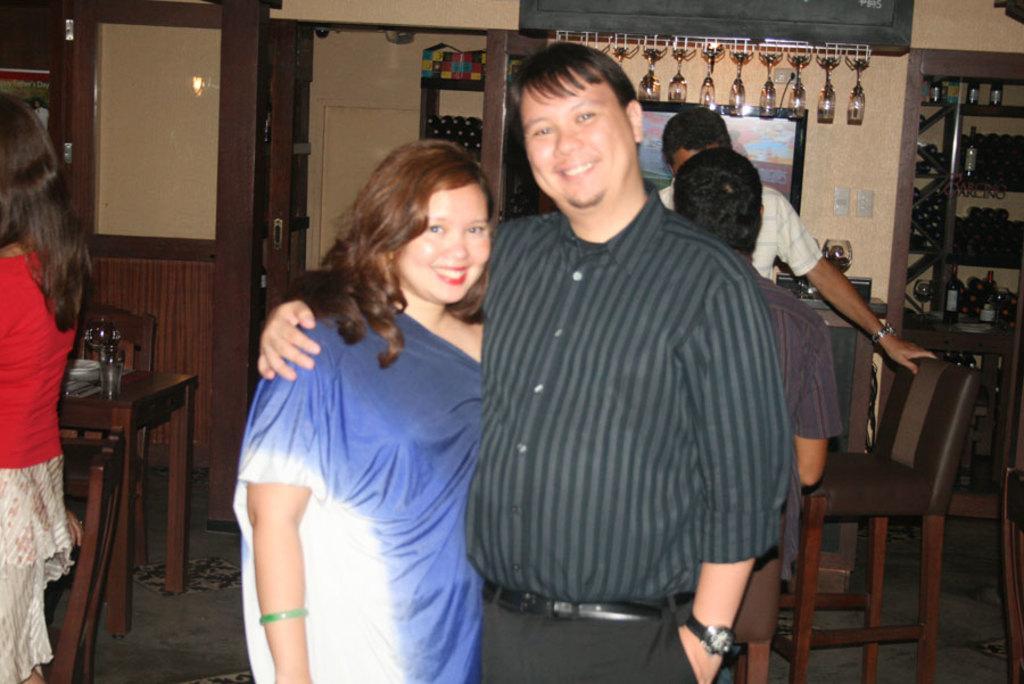Can you describe this image briefly? This woman and this man are standing and giving smile. In this race there are bottles and things. Far this persons are standing. We can able to see chairs and tables. On this table there is a glass. This is door. 